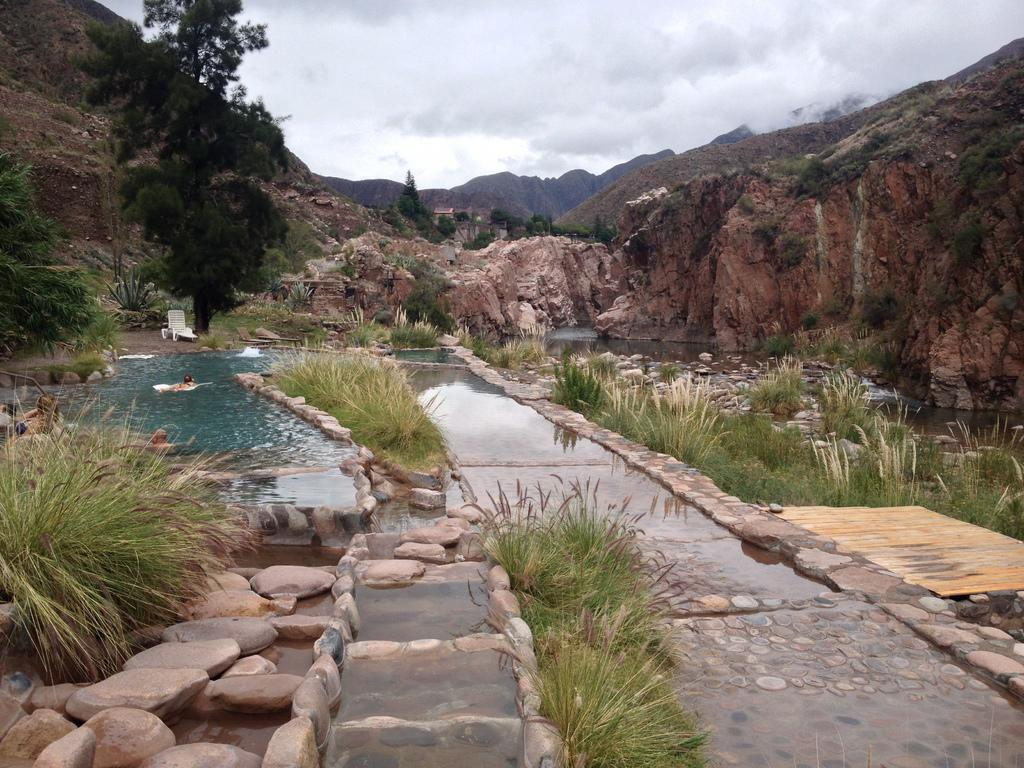What type of swimming pool is depicted in the image? There is a swimming pool made of rocks in the image. What can be seen growing near the swimming pool? Grass plants are present beside the swimming pool. What geological feature is visible in the image? There is a rock mountain in the image. What is the person in the image doing? A person is swimming in the swimming pool. What type of seating is available in the image? There is a bench in the image. What type of fight is taking place in the middle of the swimming pool? There is no fight taking place in the image, and the middle of the swimming pool is not mentioned in the facts provided. 